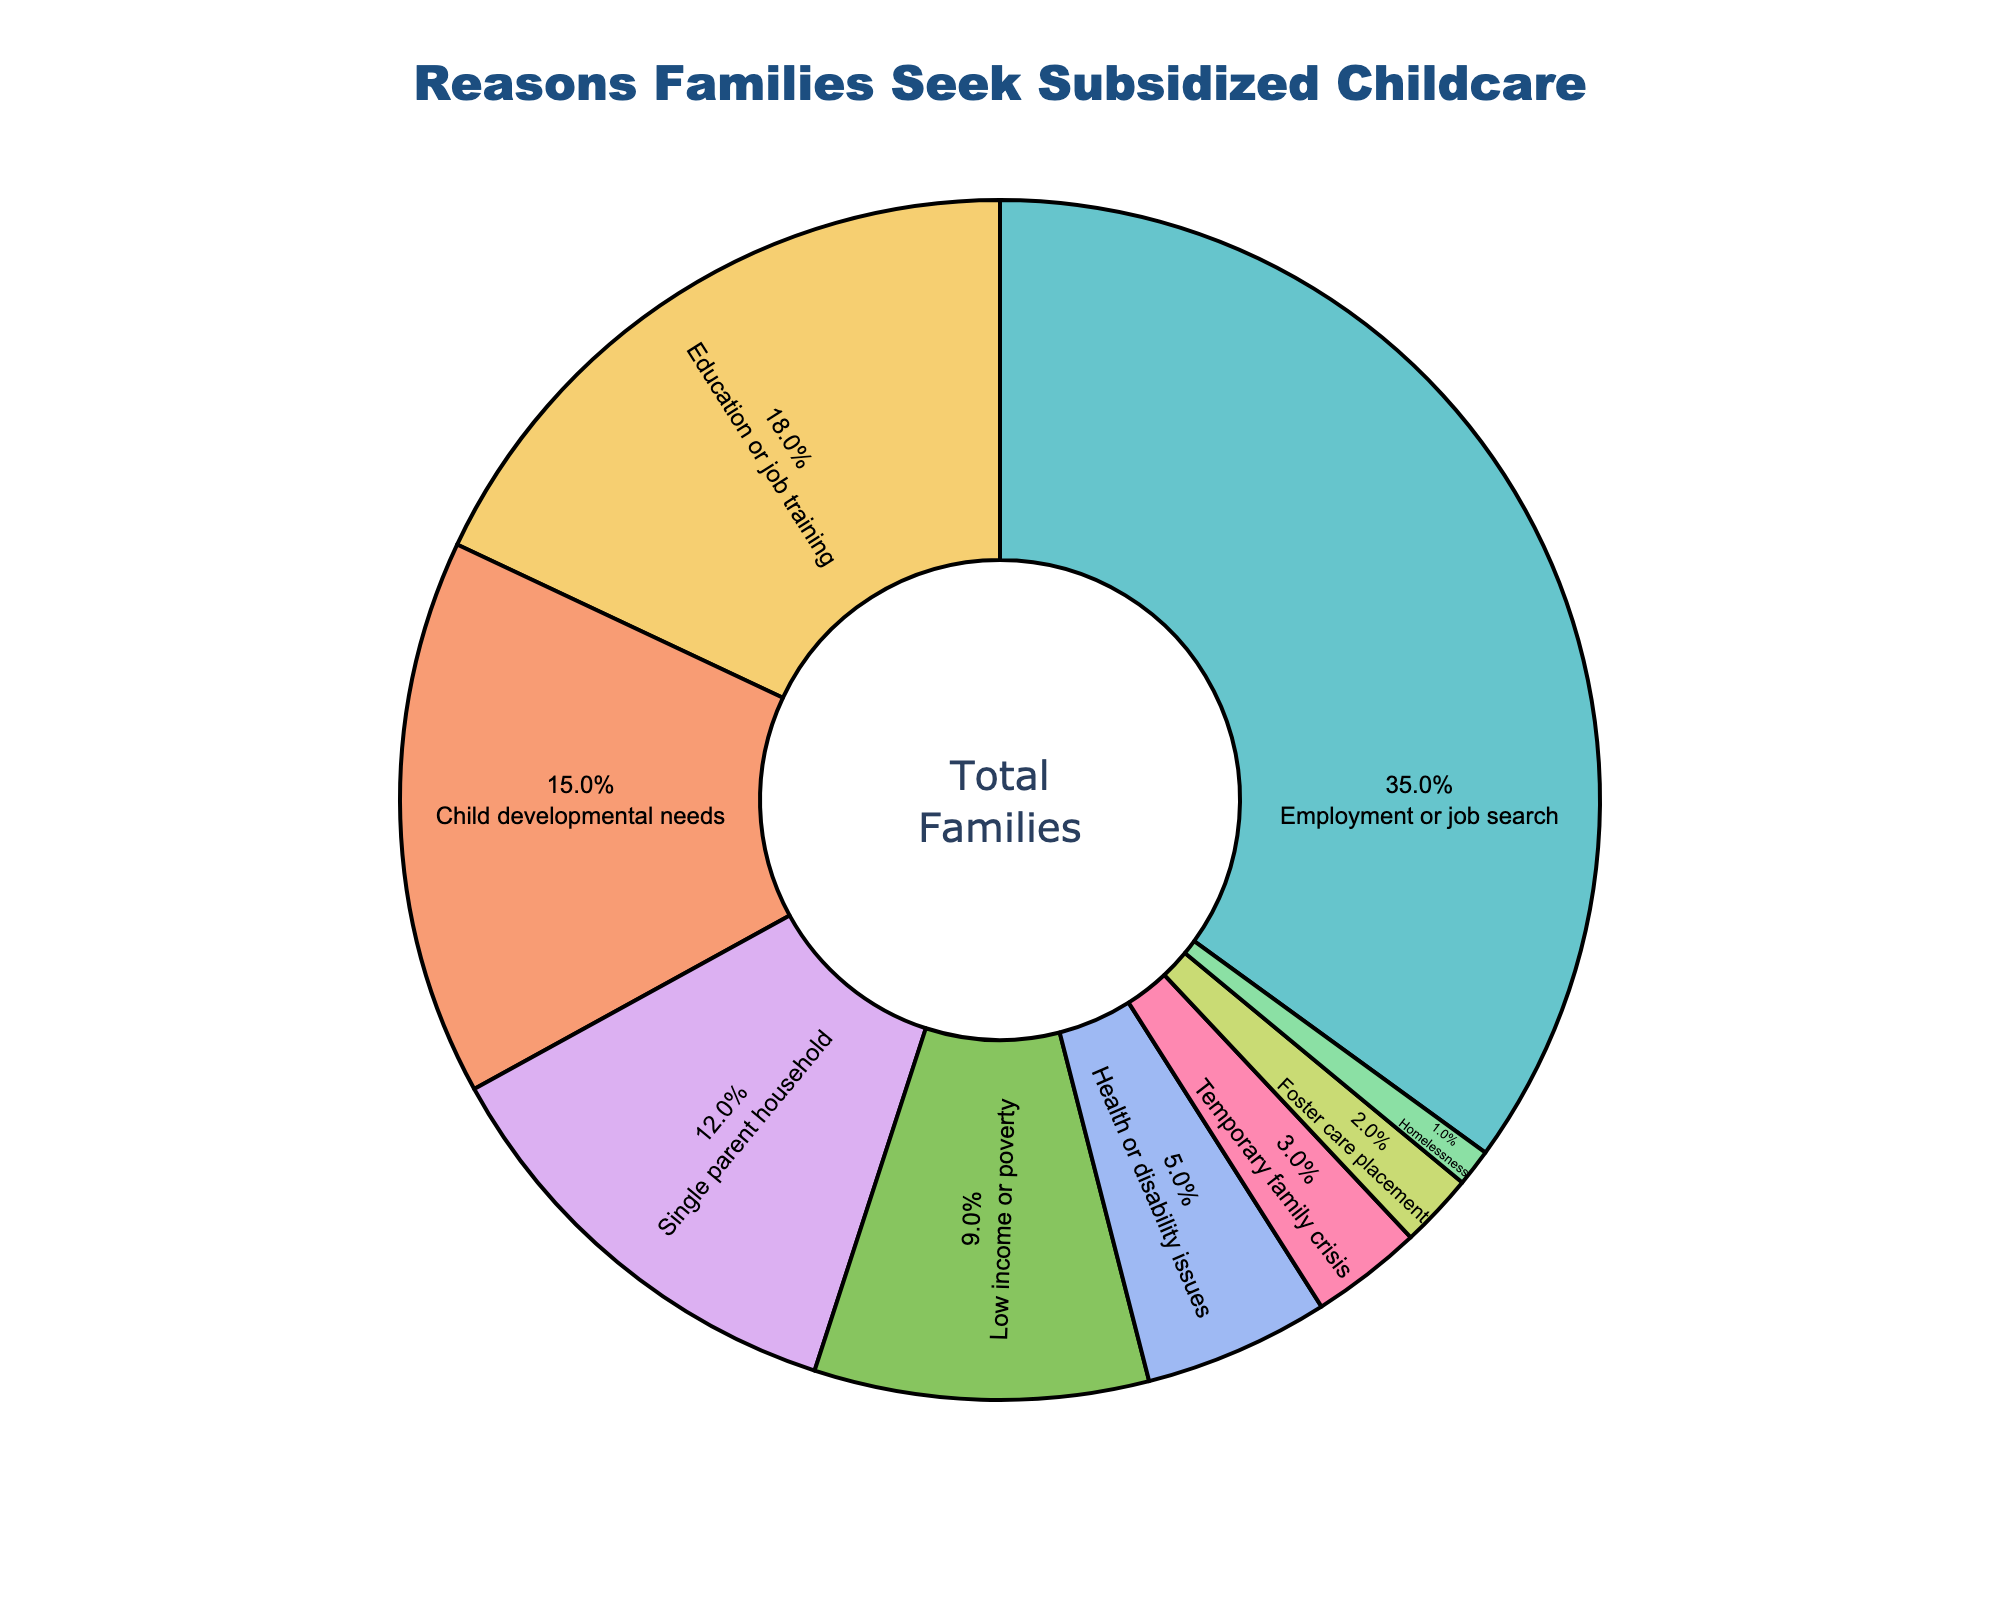Which reason has the highest percentage for families seeking subsidized childcare? By looking at the figure, identify the reason with the largest section. The slice labeled "Employment or job search" is the largest.
Answer: Employment or job search What is the combined percentage of families seeking subsidized childcare due to low income or poverty and health or disability issues? Summing the percentages for low income or poverty (9%) and health or disability issues (5%). 9% + 5% = 14%.
Answer: 14% Is the percentage of families seeking subsidized childcare for child developmental needs greater than those for education or job training? Compare the percentages for child developmental needs (15%) and education or job training (18%). 15% is less than 18%.
Answer: No What percentage of families seek subsidized childcare due to foster care placement? Look at the slice labeled "Foster care placement" to determine its percentage value.
Answer: 2% How does the percentage of single parent households compare to the low income or poverty percentage? Compare the percentages of single parent households (12%) and low income or poverty (9%). 12% is greater than 9%.
Answer: Greater Which reasons have a combined percentage equal to the percentage for employment or job search? Employment or job search is 35%. Child developmental needs (15%) + Single parent household (12%) + Low income or poverty (9%) equals 36%.
Answer: Child developmental needs, Single parent household, Low income or poverty What is the least common reason for families to seek subsidized childcare? Identify the smallest slice labeled "Homelessness" with a percentage of 1%.
Answer: Homelessness Is the sum of percentages for health or disability issues and temporary family crisis greater than the percentage for single parent household? Adding the percentages for health or disability issues (5%) and temporary family crisis (3%). 5% + 3% = 8%, which is less than 12%.
Answer: No What is the average percentage for the reasons given excluding the top reason? Exclude "Employment or job search" (35%) and find the average of the remaining values: (18% + 15% + 12% + 9% + 5% + 3% + 2% + 1%) = 65%. 65% / 8 = 8.125%.
Answer: 8.125% 